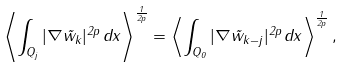Convert formula to latex. <formula><loc_0><loc_0><loc_500><loc_500>\left \langle \int _ { Q _ { j } } | \nabla \tilde { w } _ { k } | ^ { 2 p } \, d x \right \rangle ^ { \frac { 1 } { 2 p } } = \left \langle \int _ { Q _ { 0 } } | \nabla \tilde { w } _ { k - j } | ^ { 2 p } \, d x \right \rangle ^ { \frac { 1 } { 2 p } } ,</formula> 